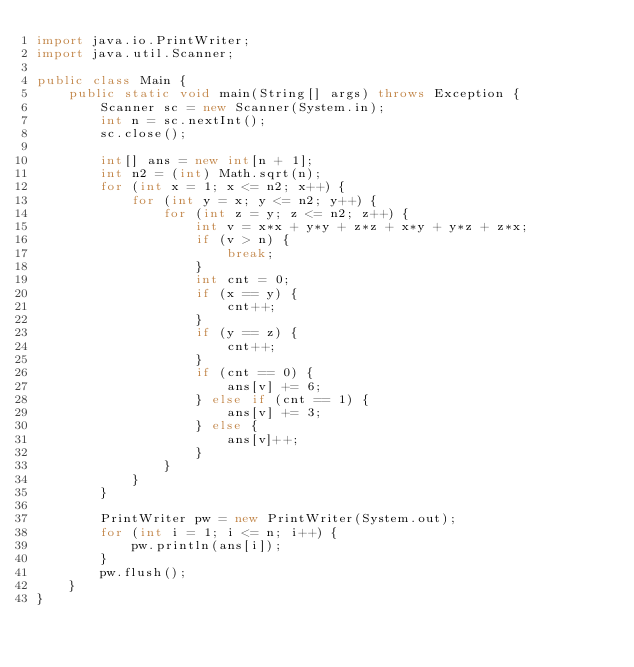<code> <loc_0><loc_0><loc_500><loc_500><_Java_>import java.io.PrintWriter;
import java.util.Scanner;

public class Main {
	public static void main(String[] args) throws Exception {
		Scanner sc = new Scanner(System.in);
		int n = sc.nextInt();
		sc.close();

		int[] ans = new int[n + 1];
		int n2 = (int) Math.sqrt(n);
		for (int x = 1; x <= n2; x++) {
			for (int y = x; y <= n2; y++) {
				for (int z = y; z <= n2; z++) {
					int v = x*x + y*y + z*z + x*y + y*z + z*x;
					if (v > n) {
						break;
					}
					int cnt = 0;
					if (x == y) {
						cnt++;
					}
					if (y == z) {
						cnt++;
					}
					if (cnt == 0) {
						ans[v] += 6;
					} else if (cnt == 1) {
						ans[v] += 3;
					} else {
						ans[v]++;
					}
				}
			}
		}

		PrintWriter pw = new PrintWriter(System.out);
		for (int i = 1; i <= n; i++) {
			pw.println(ans[i]);
		}
		pw.flush();
	}
}
</code> 